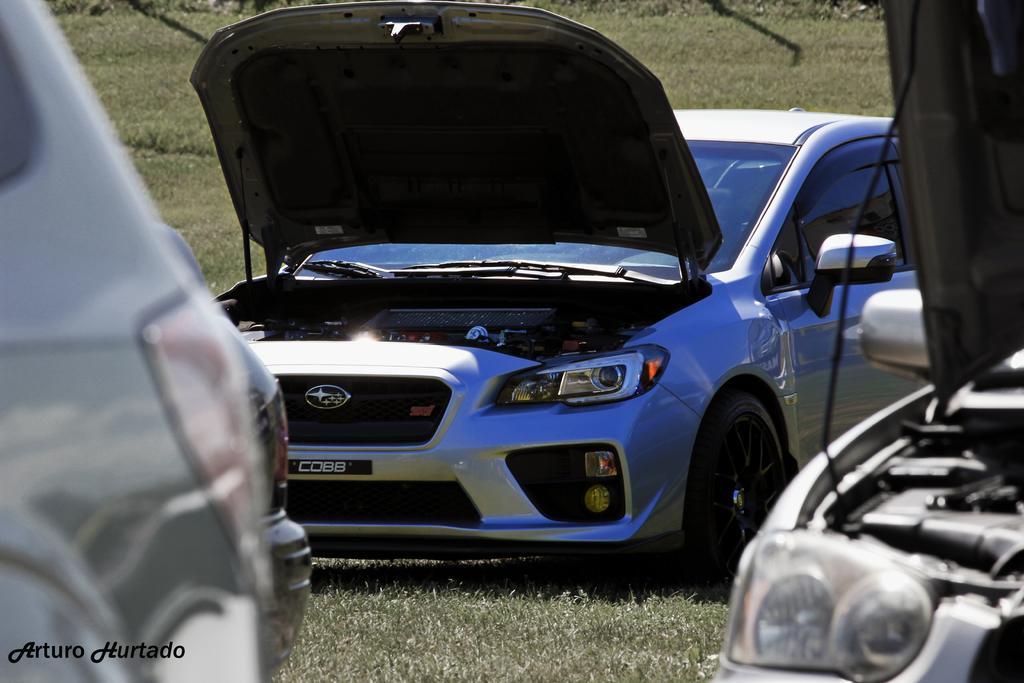Describe this image in one or two sentences. In this picture I can see few vehicles are on the grass. 